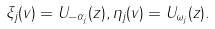<formula> <loc_0><loc_0><loc_500><loc_500>\xi _ { j } ( v ) = U _ { - \alpha _ { j } } ( z ) , \eta _ { j } ( v ) = U _ { \omega _ { j } } ( z ) .</formula> 